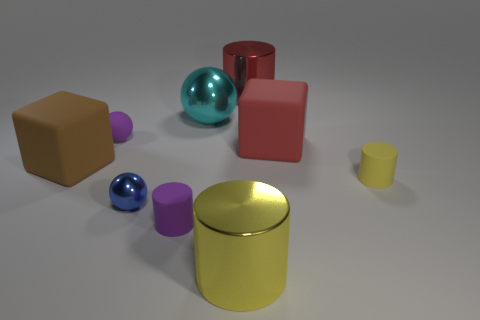There is a small cylinder that is the same color as the rubber ball; what is its material?
Your response must be concise. Rubber. There is a yellow thing that is on the right side of the red metal cylinder; is its size the same as the big red shiny cylinder?
Your response must be concise. No. Is the number of rubber balls greater than the number of big cyan cubes?
Your answer should be very brief. Yes. How many big objects are either purple spheres or gray metal objects?
Your answer should be very brief. 0. What number of other things are there of the same color as the matte sphere?
Make the answer very short. 1. What number of red cylinders are the same material as the blue sphere?
Provide a succinct answer. 1. Do the rubber cylinder on the left side of the big cyan object and the rubber sphere have the same color?
Ensure brevity in your answer.  Yes. How many red objects are either large metallic balls or big objects?
Offer a terse response. 2. Does the yellow object to the left of the yellow rubber cylinder have the same material as the brown block?
Your answer should be very brief. No. How many objects are either tiny purple balls or tiny spheres that are on the left side of the small metal object?
Offer a terse response. 1. 